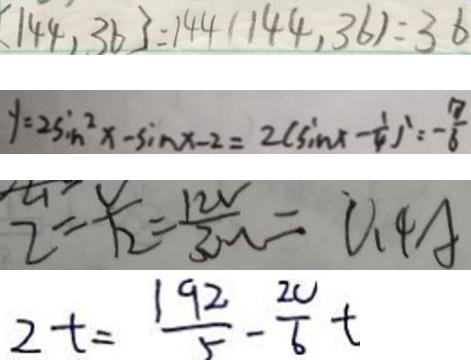Convert formula to latex. <formula><loc_0><loc_0><loc_500><loc_500>[ 1 4 4 , 3 6 ] = 1 4 4 ( 1 4 4 , 3 6 ) = 3 6 
 y = 2 \sin ^ { 2 } x - \sin x - 2 = 2 ( \sin x - \frac { 1 } { 4 } ^ { 1 } = - \frac { 7 } { 6 } 
 2 = \frac { v } { 1 2 } = \frac { 1 2 v } { 3 \Omega } = 0 . 4 A 
 2 t = \frac { 1 9 2 } { 5 } - \frac { 2 0 } { 6 } t</formula> 